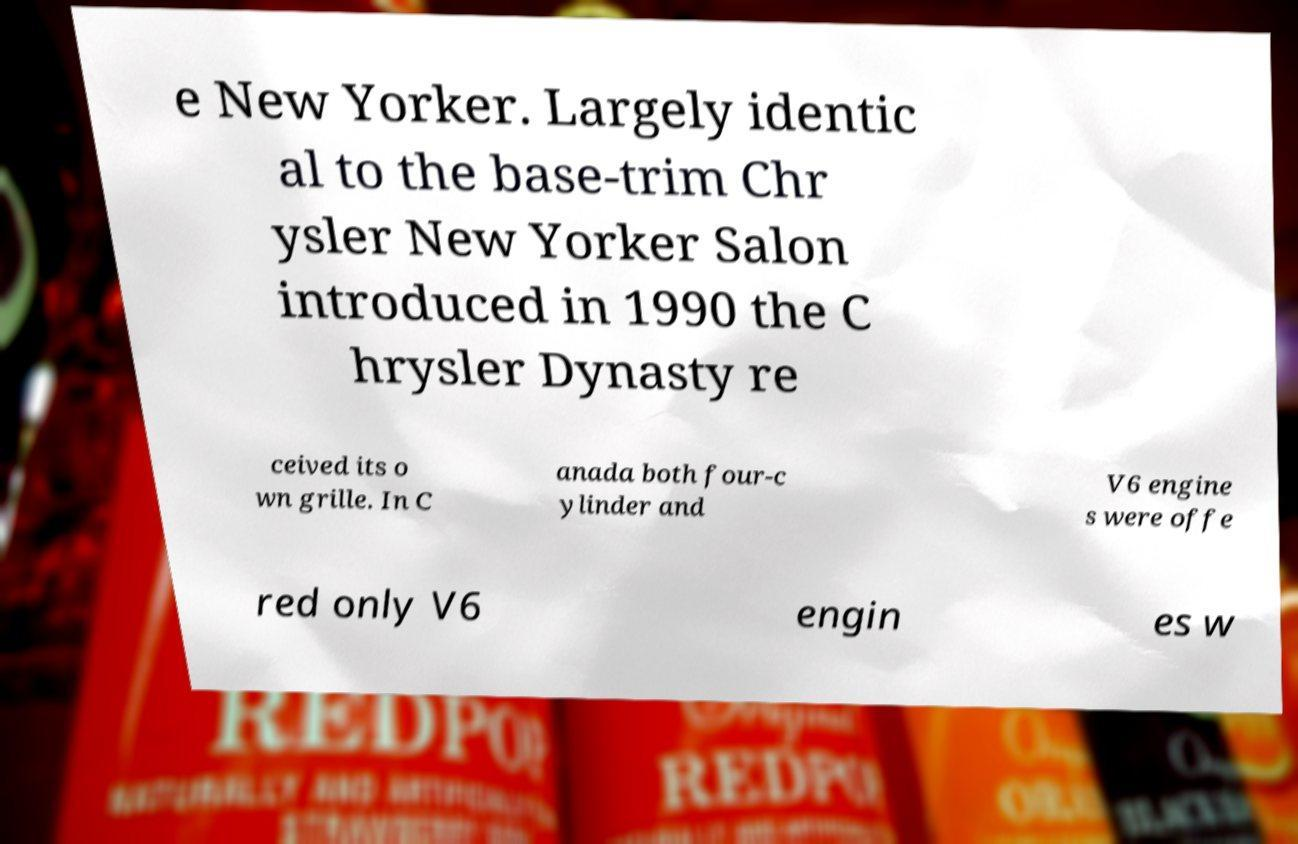There's text embedded in this image that I need extracted. Can you transcribe it verbatim? e New Yorker. Largely identic al to the base-trim Chr ysler New Yorker Salon introduced in 1990 the C hrysler Dynasty re ceived its o wn grille. In C anada both four-c ylinder and V6 engine s were offe red only V6 engin es w 